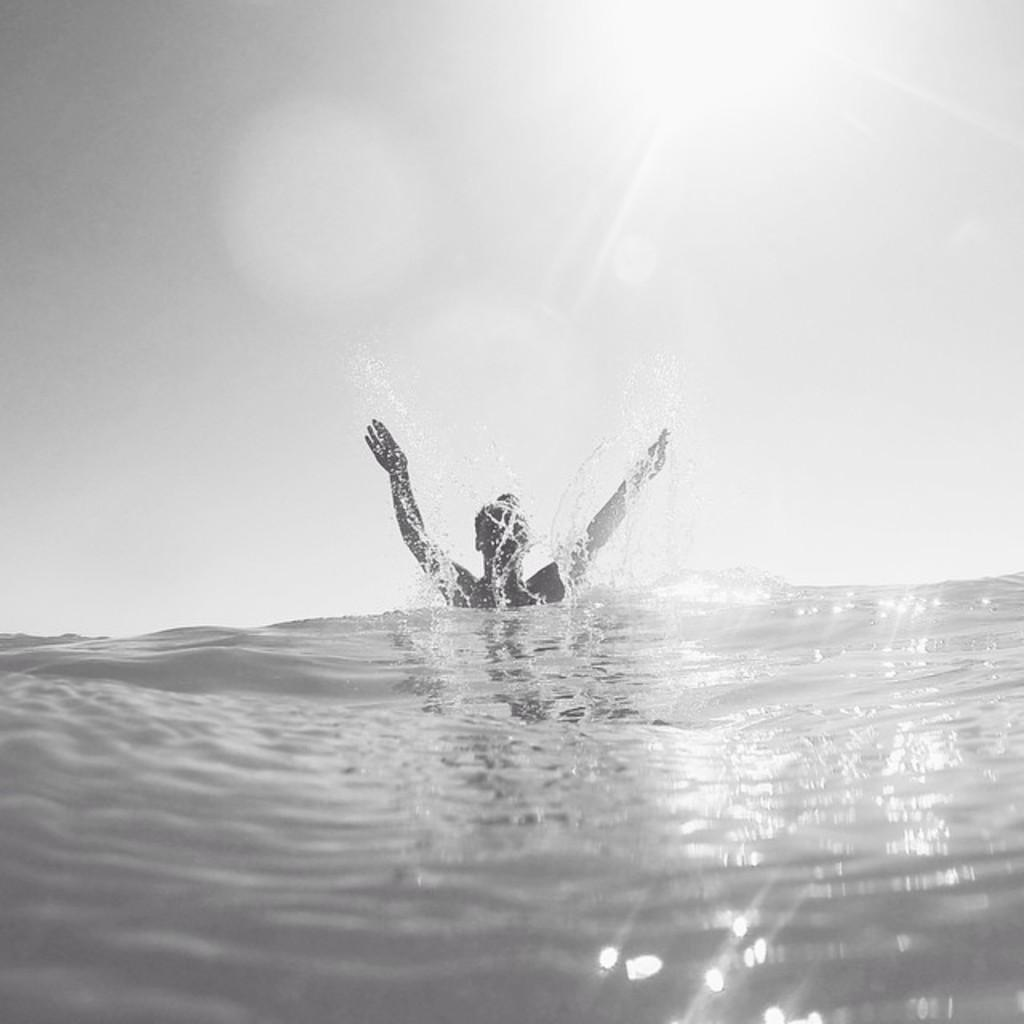What is the color scheme of the image? The image is black and white. What is the man in the image doing? The man is in a water body in the image. What else can be seen in the image besides the man? The sky is visible in the image. How would you describe the sky in the image? The sky appears to be cloudy. How many pizzas are being served at the camp in the image? There is no camp or pizzas present in the image. What type of scarecrow can be seen in the image? There is no scarecrow present in the image. 